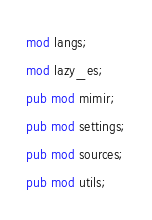<code> <loc_0><loc_0><loc_500><loc_500><_Rust_>mod langs;
mod lazy_es;
pub mod mimir;
pub mod settings;
pub mod sources;
pub mod utils;
</code> 